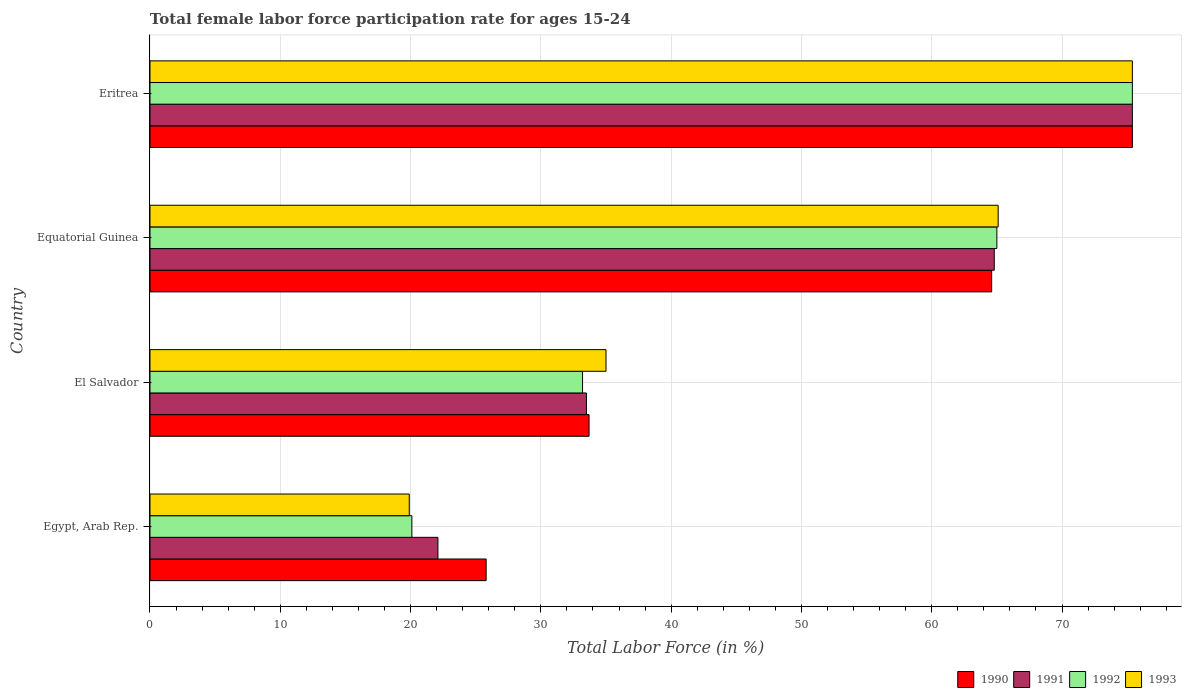Are the number of bars per tick equal to the number of legend labels?
Ensure brevity in your answer.  Yes. What is the label of the 3rd group of bars from the top?
Provide a short and direct response. El Salvador. In how many cases, is the number of bars for a given country not equal to the number of legend labels?
Make the answer very short. 0. What is the female labor force participation rate in 1993 in Equatorial Guinea?
Your answer should be compact. 65.1. Across all countries, what is the maximum female labor force participation rate in 1990?
Provide a succinct answer. 75.4. Across all countries, what is the minimum female labor force participation rate in 1991?
Keep it short and to the point. 22.1. In which country was the female labor force participation rate in 1991 maximum?
Your answer should be compact. Eritrea. In which country was the female labor force participation rate in 1992 minimum?
Ensure brevity in your answer.  Egypt, Arab Rep. What is the total female labor force participation rate in 1990 in the graph?
Your answer should be very brief. 199.5. What is the difference between the female labor force participation rate in 1991 in Equatorial Guinea and that in Eritrea?
Keep it short and to the point. -10.6. What is the difference between the female labor force participation rate in 1991 in Egypt, Arab Rep. and the female labor force participation rate in 1992 in El Salvador?
Provide a succinct answer. -11.1. What is the average female labor force participation rate in 1991 per country?
Offer a very short reply. 48.95. What is the ratio of the female labor force participation rate in 1993 in Equatorial Guinea to that in Eritrea?
Make the answer very short. 0.86. What is the difference between the highest and the second highest female labor force participation rate in 1991?
Your response must be concise. 10.6. What is the difference between the highest and the lowest female labor force participation rate in 1993?
Your response must be concise. 55.5. Is it the case that in every country, the sum of the female labor force participation rate in 1992 and female labor force participation rate in 1990 is greater than the sum of female labor force participation rate in 1993 and female labor force participation rate in 1991?
Provide a succinct answer. No. What does the 3rd bar from the bottom in Equatorial Guinea represents?
Your answer should be compact. 1992. How many bars are there?
Provide a short and direct response. 16. Are all the bars in the graph horizontal?
Provide a succinct answer. Yes. How many countries are there in the graph?
Keep it short and to the point. 4. Does the graph contain grids?
Keep it short and to the point. Yes. Where does the legend appear in the graph?
Offer a very short reply. Bottom right. How many legend labels are there?
Your answer should be very brief. 4. How are the legend labels stacked?
Provide a short and direct response. Horizontal. What is the title of the graph?
Keep it short and to the point. Total female labor force participation rate for ages 15-24. What is the label or title of the X-axis?
Your answer should be very brief. Total Labor Force (in %). What is the Total Labor Force (in %) in 1990 in Egypt, Arab Rep.?
Provide a succinct answer. 25.8. What is the Total Labor Force (in %) of 1991 in Egypt, Arab Rep.?
Keep it short and to the point. 22.1. What is the Total Labor Force (in %) of 1992 in Egypt, Arab Rep.?
Your answer should be compact. 20.1. What is the Total Labor Force (in %) in 1993 in Egypt, Arab Rep.?
Your answer should be very brief. 19.9. What is the Total Labor Force (in %) of 1990 in El Salvador?
Provide a short and direct response. 33.7. What is the Total Labor Force (in %) in 1991 in El Salvador?
Ensure brevity in your answer.  33.5. What is the Total Labor Force (in %) of 1992 in El Salvador?
Your answer should be very brief. 33.2. What is the Total Labor Force (in %) in 1993 in El Salvador?
Your answer should be compact. 35. What is the Total Labor Force (in %) of 1990 in Equatorial Guinea?
Your response must be concise. 64.6. What is the Total Labor Force (in %) in 1991 in Equatorial Guinea?
Provide a short and direct response. 64.8. What is the Total Labor Force (in %) of 1992 in Equatorial Guinea?
Offer a very short reply. 65. What is the Total Labor Force (in %) of 1993 in Equatorial Guinea?
Ensure brevity in your answer.  65.1. What is the Total Labor Force (in %) of 1990 in Eritrea?
Provide a short and direct response. 75.4. What is the Total Labor Force (in %) of 1991 in Eritrea?
Your answer should be very brief. 75.4. What is the Total Labor Force (in %) of 1992 in Eritrea?
Ensure brevity in your answer.  75.4. What is the Total Labor Force (in %) of 1993 in Eritrea?
Keep it short and to the point. 75.4. Across all countries, what is the maximum Total Labor Force (in %) in 1990?
Your response must be concise. 75.4. Across all countries, what is the maximum Total Labor Force (in %) of 1991?
Keep it short and to the point. 75.4. Across all countries, what is the maximum Total Labor Force (in %) in 1992?
Your answer should be compact. 75.4. Across all countries, what is the maximum Total Labor Force (in %) of 1993?
Offer a very short reply. 75.4. Across all countries, what is the minimum Total Labor Force (in %) in 1990?
Your response must be concise. 25.8. Across all countries, what is the minimum Total Labor Force (in %) in 1991?
Provide a succinct answer. 22.1. Across all countries, what is the minimum Total Labor Force (in %) in 1992?
Keep it short and to the point. 20.1. Across all countries, what is the minimum Total Labor Force (in %) in 1993?
Offer a very short reply. 19.9. What is the total Total Labor Force (in %) in 1990 in the graph?
Offer a terse response. 199.5. What is the total Total Labor Force (in %) in 1991 in the graph?
Your answer should be very brief. 195.8. What is the total Total Labor Force (in %) of 1992 in the graph?
Give a very brief answer. 193.7. What is the total Total Labor Force (in %) of 1993 in the graph?
Provide a short and direct response. 195.4. What is the difference between the Total Labor Force (in %) in 1990 in Egypt, Arab Rep. and that in El Salvador?
Your response must be concise. -7.9. What is the difference between the Total Labor Force (in %) in 1991 in Egypt, Arab Rep. and that in El Salvador?
Your answer should be compact. -11.4. What is the difference between the Total Labor Force (in %) in 1992 in Egypt, Arab Rep. and that in El Salvador?
Offer a very short reply. -13.1. What is the difference between the Total Labor Force (in %) in 1993 in Egypt, Arab Rep. and that in El Salvador?
Your answer should be compact. -15.1. What is the difference between the Total Labor Force (in %) in 1990 in Egypt, Arab Rep. and that in Equatorial Guinea?
Make the answer very short. -38.8. What is the difference between the Total Labor Force (in %) of 1991 in Egypt, Arab Rep. and that in Equatorial Guinea?
Ensure brevity in your answer.  -42.7. What is the difference between the Total Labor Force (in %) in 1992 in Egypt, Arab Rep. and that in Equatorial Guinea?
Offer a very short reply. -44.9. What is the difference between the Total Labor Force (in %) in 1993 in Egypt, Arab Rep. and that in Equatorial Guinea?
Provide a succinct answer. -45.2. What is the difference between the Total Labor Force (in %) of 1990 in Egypt, Arab Rep. and that in Eritrea?
Provide a succinct answer. -49.6. What is the difference between the Total Labor Force (in %) in 1991 in Egypt, Arab Rep. and that in Eritrea?
Your answer should be compact. -53.3. What is the difference between the Total Labor Force (in %) of 1992 in Egypt, Arab Rep. and that in Eritrea?
Your answer should be very brief. -55.3. What is the difference between the Total Labor Force (in %) in 1993 in Egypt, Arab Rep. and that in Eritrea?
Your response must be concise. -55.5. What is the difference between the Total Labor Force (in %) in 1990 in El Salvador and that in Equatorial Guinea?
Make the answer very short. -30.9. What is the difference between the Total Labor Force (in %) of 1991 in El Salvador and that in Equatorial Guinea?
Make the answer very short. -31.3. What is the difference between the Total Labor Force (in %) of 1992 in El Salvador and that in Equatorial Guinea?
Keep it short and to the point. -31.8. What is the difference between the Total Labor Force (in %) of 1993 in El Salvador and that in Equatorial Guinea?
Keep it short and to the point. -30.1. What is the difference between the Total Labor Force (in %) in 1990 in El Salvador and that in Eritrea?
Your response must be concise. -41.7. What is the difference between the Total Labor Force (in %) in 1991 in El Salvador and that in Eritrea?
Provide a succinct answer. -41.9. What is the difference between the Total Labor Force (in %) in 1992 in El Salvador and that in Eritrea?
Keep it short and to the point. -42.2. What is the difference between the Total Labor Force (in %) in 1993 in El Salvador and that in Eritrea?
Provide a short and direct response. -40.4. What is the difference between the Total Labor Force (in %) of 1992 in Equatorial Guinea and that in Eritrea?
Your response must be concise. -10.4. What is the difference between the Total Labor Force (in %) in 1991 in Egypt, Arab Rep. and the Total Labor Force (in %) in 1992 in El Salvador?
Offer a very short reply. -11.1. What is the difference between the Total Labor Force (in %) of 1991 in Egypt, Arab Rep. and the Total Labor Force (in %) of 1993 in El Salvador?
Offer a very short reply. -12.9. What is the difference between the Total Labor Force (in %) of 1992 in Egypt, Arab Rep. and the Total Labor Force (in %) of 1993 in El Salvador?
Make the answer very short. -14.9. What is the difference between the Total Labor Force (in %) in 1990 in Egypt, Arab Rep. and the Total Labor Force (in %) in 1991 in Equatorial Guinea?
Make the answer very short. -39. What is the difference between the Total Labor Force (in %) in 1990 in Egypt, Arab Rep. and the Total Labor Force (in %) in 1992 in Equatorial Guinea?
Offer a very short reply. -39.2. What is the difference between the Total Labor Force (in %) in 1990 in Egypt, Arab Rep. and the Total Labor Force (in %) in 1993 in Equatorial Guinea?
Make the answer very short. -39.3. What is the difference between the Total Labor Force (in %) in 1991 in Egypt, Arab Rep. and the Total Labor Force (in %) in 1992 in Equatorial Guinea?
Keep it short and to the point. -42.9. What is the difference between the Total Labor Force (in %) in 1991 in Egypt, Arab Rep. and the Total Labor Force (in %) in 1993 in Equatorial Guinea?
Make the answer very short. -43. What is the difference between the Total Labor Force (in %) of 1992 in Egypt, Arab Rep. and the Total Labor Force (in %) of 1993 in Equatorial Guinea?
Provide a short and direct response. -45. What is the difference between the Total Labor Force (in %) of 1990 in Egypt, Arab Rep. and the Total Labor Force (in %) of 1991 in Eritrea?
Your answer should be very brief. -49.6. What is the difference between the Total Labor Force (in %) in 1990 in Egypt, Arab Rep. and the Total Labor Force (in %) in 1992 in Eritrea?
Your answer should be very brief. -49.6. What is the difference between the Total Labor Force (in %) of 1990 in Egypt, Arab Rep. and the Total Labor Force (in %) of 1993 in Eritrea?
Make the answer very short. -49.6. What is the difference between the Total Labor Force (in %) of 1991 in Egypt, Arab Rep. and the Total Labor Force (in %) of 1992 in Eritrea?
Make the answer very short. -53.3. What is the difference between the Total Labor Force (in %) of 1991 in Egypt, Arab Rep. and the Total Labor Force (in %) of 1993 in Eritrea?
Your answer should be very brief. -53.3. What is the difference between the Total Labor Force (in %) of 1992 in Egypt, Arab Rep. and the Total Labor Force (in %) of 1993 in Eritrea?
Keep it short and to the point. -55.3. What is the difference between the Total Labor Force (in %) of 1990 in El Salvador and the Total Labor Force (in %) of 1991 in Equatorial Guinea?
Make the answer very short. -31.1. What is the difference between the Total Labor Force (in %) in 1990 in El Salvador and the Total Labor Force (in %) in 1992 in Equatorial Guinea?
Your answer should be compact. -31.3. What is the difference between the Total Labor Force (in %) in 1990 in El Salvador and the Total Labor Force (in %) in 1993 in Equatorial Guinea?
Your response must be concise. -31.4. What is the difference between the Total Labor Force (in %) in 1991 in El Salvador and the Total Labor Force (in %) in 1992 in Equatorial Guinea?
Keep it short and to the point. -31.5. What is the difference between the Total Labor Force (in %) in 1991 in El Salvador and the Total Labor Force (in %) in 1993 in Equatorial Guinea?
Keep it short and to the point. -31.6. What is the difference between the Total Labor Force (in %) of 1992 in El Salvador and the Total Labor Force (in %) of 1993 in Equatorial Guinea?
Ensure brevity in your answer.  -31.9. What is the difference between the Total Labor Force (in %) of 1990 in El Salvador and the Total Labor Force (in %) of 1991 in Eritrea?
Offer a terse response. -41.7. What is the difference between the Total Labor Force (in %) in 1990 in El Salvador and the Total Labor Force (in %) in 1992 in Eritrea?
Your answer should be very brief. -41.7. What is the difference between the Total Labor Force (in %) in 1990 in El Salvador and the Total Labor Force (in %) in 1993 in Eritrea?
Make the answer very short. -41.7. What is the difference between the Total Labor Force (in %) in 1991 in El Salvador and the Total Labor Force (in %) in 1992 in Eritrea?
Provide a succinct answer. -41.9. What is the difference between the Total Labor Force (in %) in 1991 in El Salvador and the Total Labor Force (in %) in 1993 in Eritrea?
Offer a very short reply. -41.9. What is the difference between the Total Labor Force (in %) of 1992 in El Salvador and the Total Labor Force (in %) of 1993 in Eritrea?
Provide a succinct answer. -42.2. What is the difference between the Total Labor Force (in %) of 1990 in Equatorial Guinea and the Total Labor Force (in %) of 1991 in Eritrea?
Your answer should be very brief. -10.8. What is the difference between the Total Labor Force (in %) in 1990 in Equatorial Guinea and the Total Labor Force (in %) in 1992 in Eritrea?
Make the answer very short. -10.8. What is the average Total Labor Force (in %) of 1990 per country?
Give a very brief answer. 49.88. What is the average Total Labor Force (in %) of 1991 per country?
Your answer should be very brief. 48.95. What is the average Total Labor Force (in %) of 1992 per country?
Make the answer very short. 48.42. What is the average Total Labor Force (in %) in 1993 per country?
Your answer should be very brief. 48.85. What is the difference between the Total Labor Force (in %) in 1990 and Total Labor Force (in %) in 1991 in Egypt, Arab Rep.?
Give a very brief answer. 3.7. What is the difference between the Total Labor Force (in %) in 1990 and Total Labor Force (in %) in 1992 in Egypt, Arab Rep.?
Provide a succinct answer. 5.7. What is the difference between the Total Labor Force (in %) of 1990 and Total Labor Force (in %) of 1993 in Egypt, Arab Rep.?
Your answer should be very brief. 5.9. What is the difference between the Total Labor Force (in %) of 1991 and Total Labor Force (in %) of 1992 in Egypt, Arab Rep.?
Your answer should be very brief. 2. What is the difference between the Total Labor Force (in %) of 1991 and Total Labor Force (in %) of 1993 in Egypt, Arab Rep.?
Ensure brevity in your answer.  2.2. What is the difference between the Total Labor Force (in %) of 1992 and Total Labor Force (in %) of 1993 in Egypt, Arab Rep.?
Offer a very short reply. 0.2. What is the difference between the Total Labor Force (in %) in 1990 and Total Labor Force (in %) in 1992 in El Salvador?
Ensure brevity in your answer.  0.5. What is the difference between the Total Labor Force (in %) of 1990 and Total Labor Force (in %) of 1993 in El Salvador?
Your response must be concise. -1.3. What is the difference between the Total Labor Force (in %) of 1992 and Total Labor Force (in %) of 1993 in El Salvador?
Give a very brief answer. -1.8. What is the difference between the Total Labor Force (in %) in 1991 and Total Labor Force (in %) in 1993 in Equatorial Guinea?
Offer a very short reply. -0.3. What is the difference between the Total Labor Force (in %) in 1992 and Total Labor Force (in %) in 1993 in Equatorial Guinea?
Provide a short and direct response. -0.1. What is the difference between the Total Labor Force (in %) in 1990 and Total Labor Force (in %) in 1992 in Eritrea?
Make the answer very short. 0. What is the difference between the Total Labor Force (in %) of 1991 and Total Labor Force (in %) of 1992 in Eritrea?
Make the answer very short. 0. What is the difference between the Total Labor Force (in %) in 1991 and Total Labor Force (in %) in 1993 in Eritrea?
Your response must be concise. 0. What is the ratio of the Total Labor Force (in %) in 1990 in Egypt, Arab Rep. to that in El Salvador?
Keep it short and to the point. 0.77. What is the ratio of the Total Labor Force (in %) of 1991 in Egypt, Arab Rep. to that in El Salvador?
Provide a short and direct response. 0.66. What is the ratio of the Total Labor Force (in %) of 1992 in Egypt, Arab Rep. to that in El Salvador?
Offer a very short reply. 0.61. What is the ratio of the Total Labor Force (in %) in 1993 in Egypt, Arab Rep. to that in El Salvador?
Give a very brief answer. 0.57. What is the ratio of the Total Labor Force (in %) in 1990 in Egypt, Arab Rep. to that in Equatorial Guinea?
Offer a very short reply. 0.4. What is the ratio of the Total Labor Force (in %) of 1991 in Egypt, Arab Rep. to that in Equatorial Guinea?
Keep it short and to the point. 0.34. What is the ratio of the Total Labor Force (in %) of 1992 in Egypt, Arab Rep. to that in Equatorial Guinea?
Offer a terse response. 0.31. What is the ratio of the Total Labor Force (in %) of 1993 in Egypt, Arab Rep. to that in Equatorial Guinea?
Keep it short and to the point. 0.31. What is the ratio of the Total Labor Force (in %) in 1990 in Egypt, Arab Rep. to that in Eritrea?
Provide a short and direct response. 0.34. What is the ratio of the Total Labor Force (in %) of 1991 in Egypt, Arab Rep. to that in Eritrea?
Ensure brevity in your answer.  0.29. What is the ratio of the Total Labor Force (in %) in 1992 in Egypt, Arab Rep. to that in Eritrea?
Give a very brief answer. 0.27. What is the ratio of the Total Labor Force (in %) of 1993 in Egypt, Arab Rep. to that in Eritrea?
Make the answer very short. 0.26. What is the ratio of the Total Labor Force (in %) of 1990 in El Salvador to that in Equatorial Guinea?
Offer a terse response. 0.52. What is the ratio of the Total Labor Force (in %) in 1991 in El Salvador to that in Equatorial Guinea?
Ensure brevity in your answer.  0.52. What is the ratio of the Total Labor Force (in %) in 1992 in El Salvador to that in Equatorial Guinea?
Your answer should be very brief. 0.51. What is the ratio of the Total Labor Force (in %) of 1993 in El Salvador to that in Equatorial Guinea?
Offer a very short reply. 0.54. What is the ratio of the Total Labor Force (in %) in 1990 in El Salvador to that in Eritrea?
Your answer should be compact. 0.45. What is the ratio of the Total Labor Force (in %) in 1991 in El Salvador to that in Eritrea?
Your answer should be very brief. 0.44. What is the ratio of the Total Labor Force (in %) of 1992 in El Salvador to that in Eritrea?
Offer a terse response. 0.44. What is the ratio of the Total Labor Force (in %) of 1993 in El Salvador to that in Eritrea?
Make the answer very short. 0.46. What is the ratio of the Total Labor Force (in %) of 1990 in Equatorial Guinea to that in Eritrea?
Give a very brief answer. 0.86. What is the ratio of the Total Labor Force (in %) of 1991 in Equatorial Guinea to that in Eritrea?
Your answer should be very brief. 0.86. What is the ratio of the Total Labor Force (in %) in 1992 in Equatorial Guinea to that in Eritrea?
Offer a terse response. 0.86. What is the ratio of the Total Labor Force (in %) of 1993 in Equatorial Guinea to that in Eritrea?
Give a very brief answer. 0.86. What is the difference between the highest and the second highest Total Labor Force (in %) in 1990?
Provide a short and direct response. 10.8. What is the difference between the highest and the second highest Total Labor Force (in %) of 1991?
Offer a terse response. 10.6. What is the difference between the highest and the lowest Total Labor Force (in %) of 1990?
Offer a terse response. 49.6. What is the difference between the highest and the lowest Total Labor Force (in %) of 1991?
Your answer should be compact. 53.3. What is the difference between the highest and the lowest Total Labor Force (in %) of 1992?
Your response must be concise. 55.3. What is the difference between the highest and the lowest Total Labor Force (in %) in 1993?
Provide a short and direct response. 55.5. 